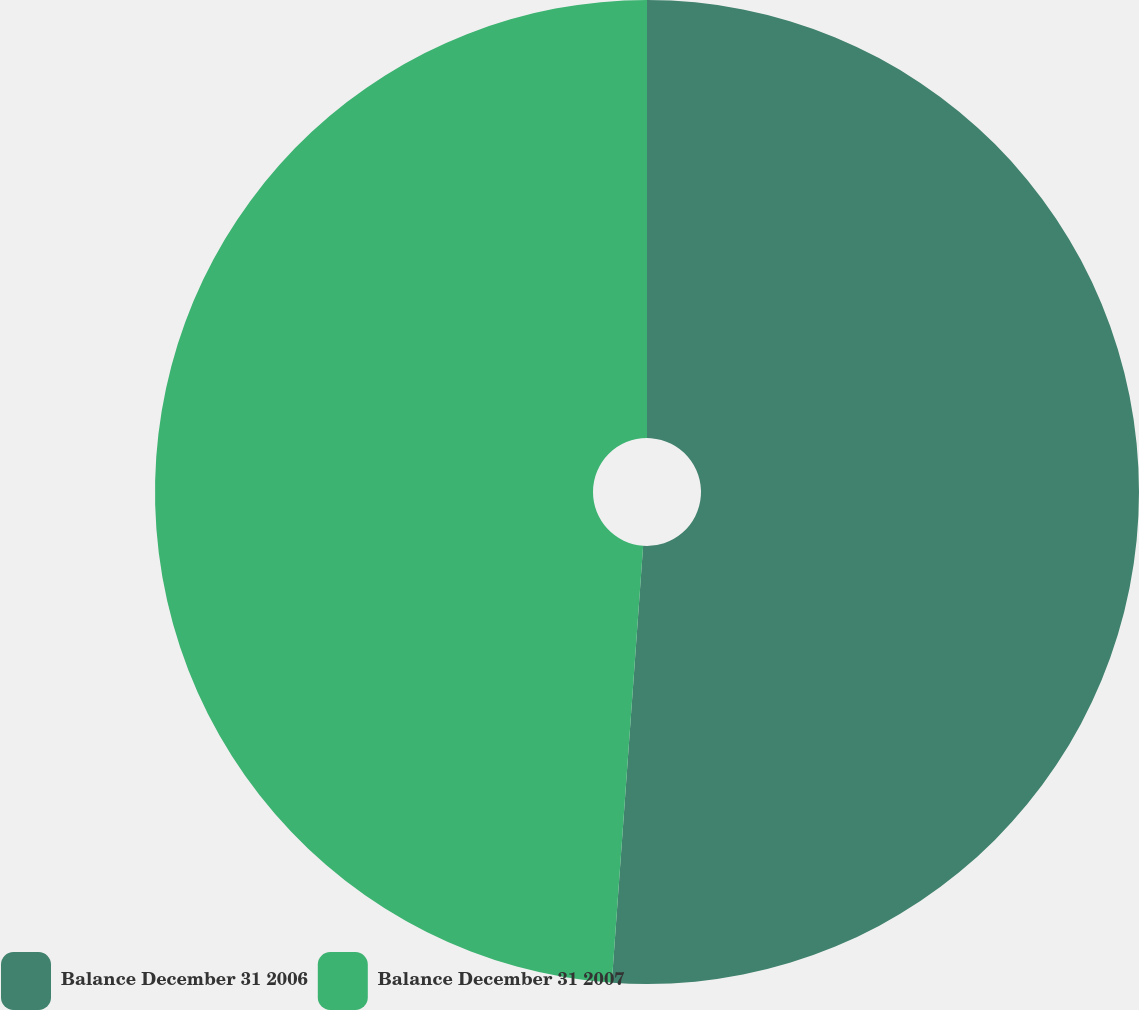Convert chart to OTSL. <chart><loc_0><loc_0><loc_500><loc_500><pie_chart><fcel>Balance December 31 2006<fcel>Balance December 31 2007<nl><fcel>51.14%<fcel>48.86%<nl></chart> 